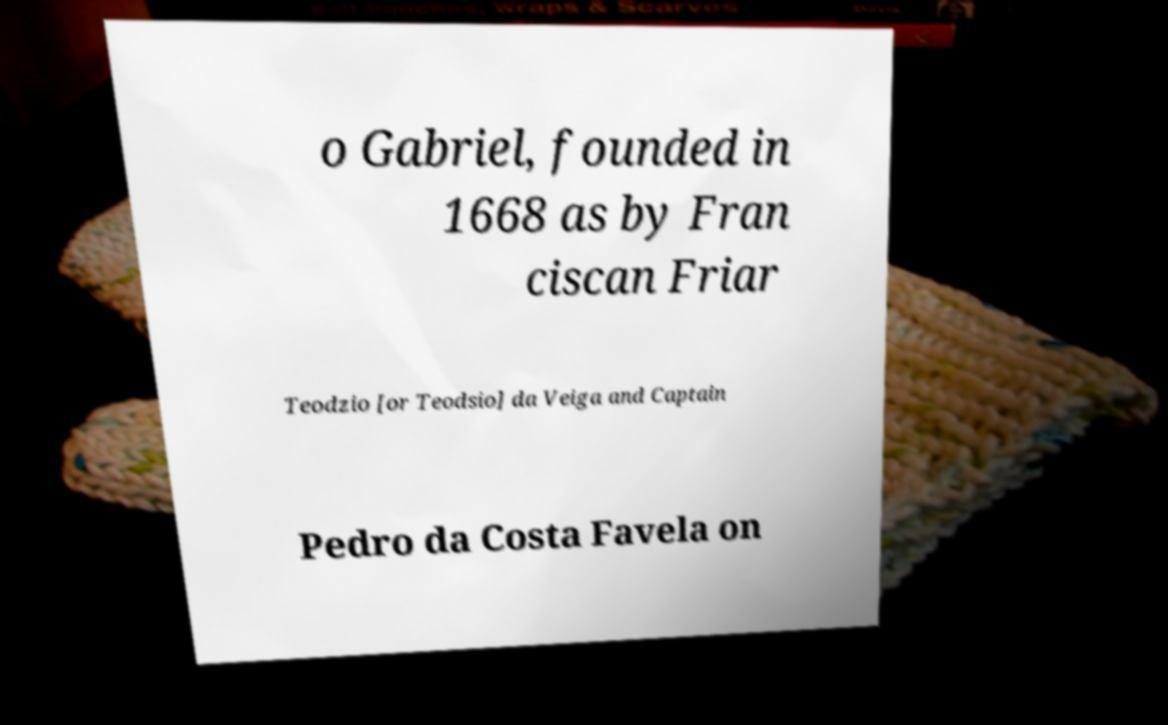Can you accurately transcribe the text from the provided image for me? o Gabriel, founded in 1668 as by Fran ciscan Friar Teodzio [or Teodsio] da Veiga and Captain Pedro da Costa Favela on 